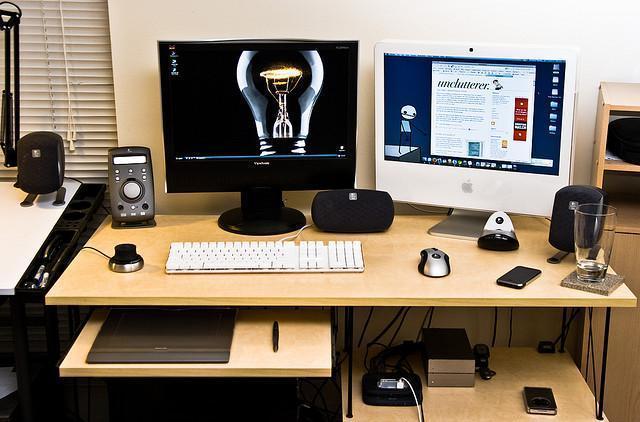How many monitors does the desk have?
Give a very brief answer. 2. How many tvs are there?
Give a very brief answer. 2. How many motorcycles are on the road?
Give a very brief answer. 0. 